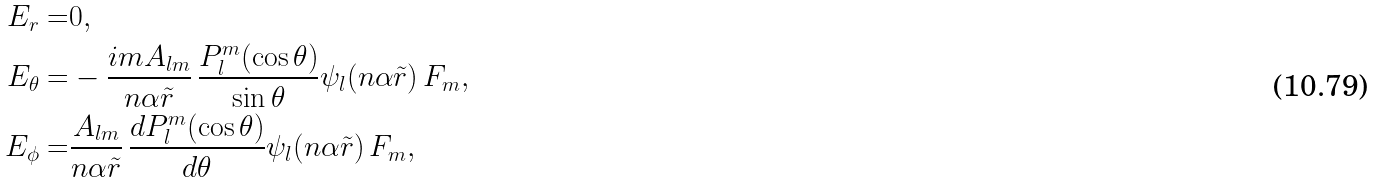Convert formula to latex. <formula><loc_0><loc_0><loc_500><loc_500>E _ { r } = & 0 , \\ E _ { \theta } = & - \frac { i m A _ { l m } } { n \alpha \tilde { r } } \, \frac { P _ { l } ^ { m } ( \cos \theta ) } { \sin \theta } \psi _ { l } ( n \alpha \tilde { r } ) \, F _ { m } , \\ E _ { \phi } = & \frac { A _ { l m } } { n \alpha \tilde { r } } \, \frac { d P _ { l } ^ { m } ( \cos \theta ) } { d \theta } \psi _ { l } ( n \alpha \tilde { r } ) \, F _ { m } ,</formula> 